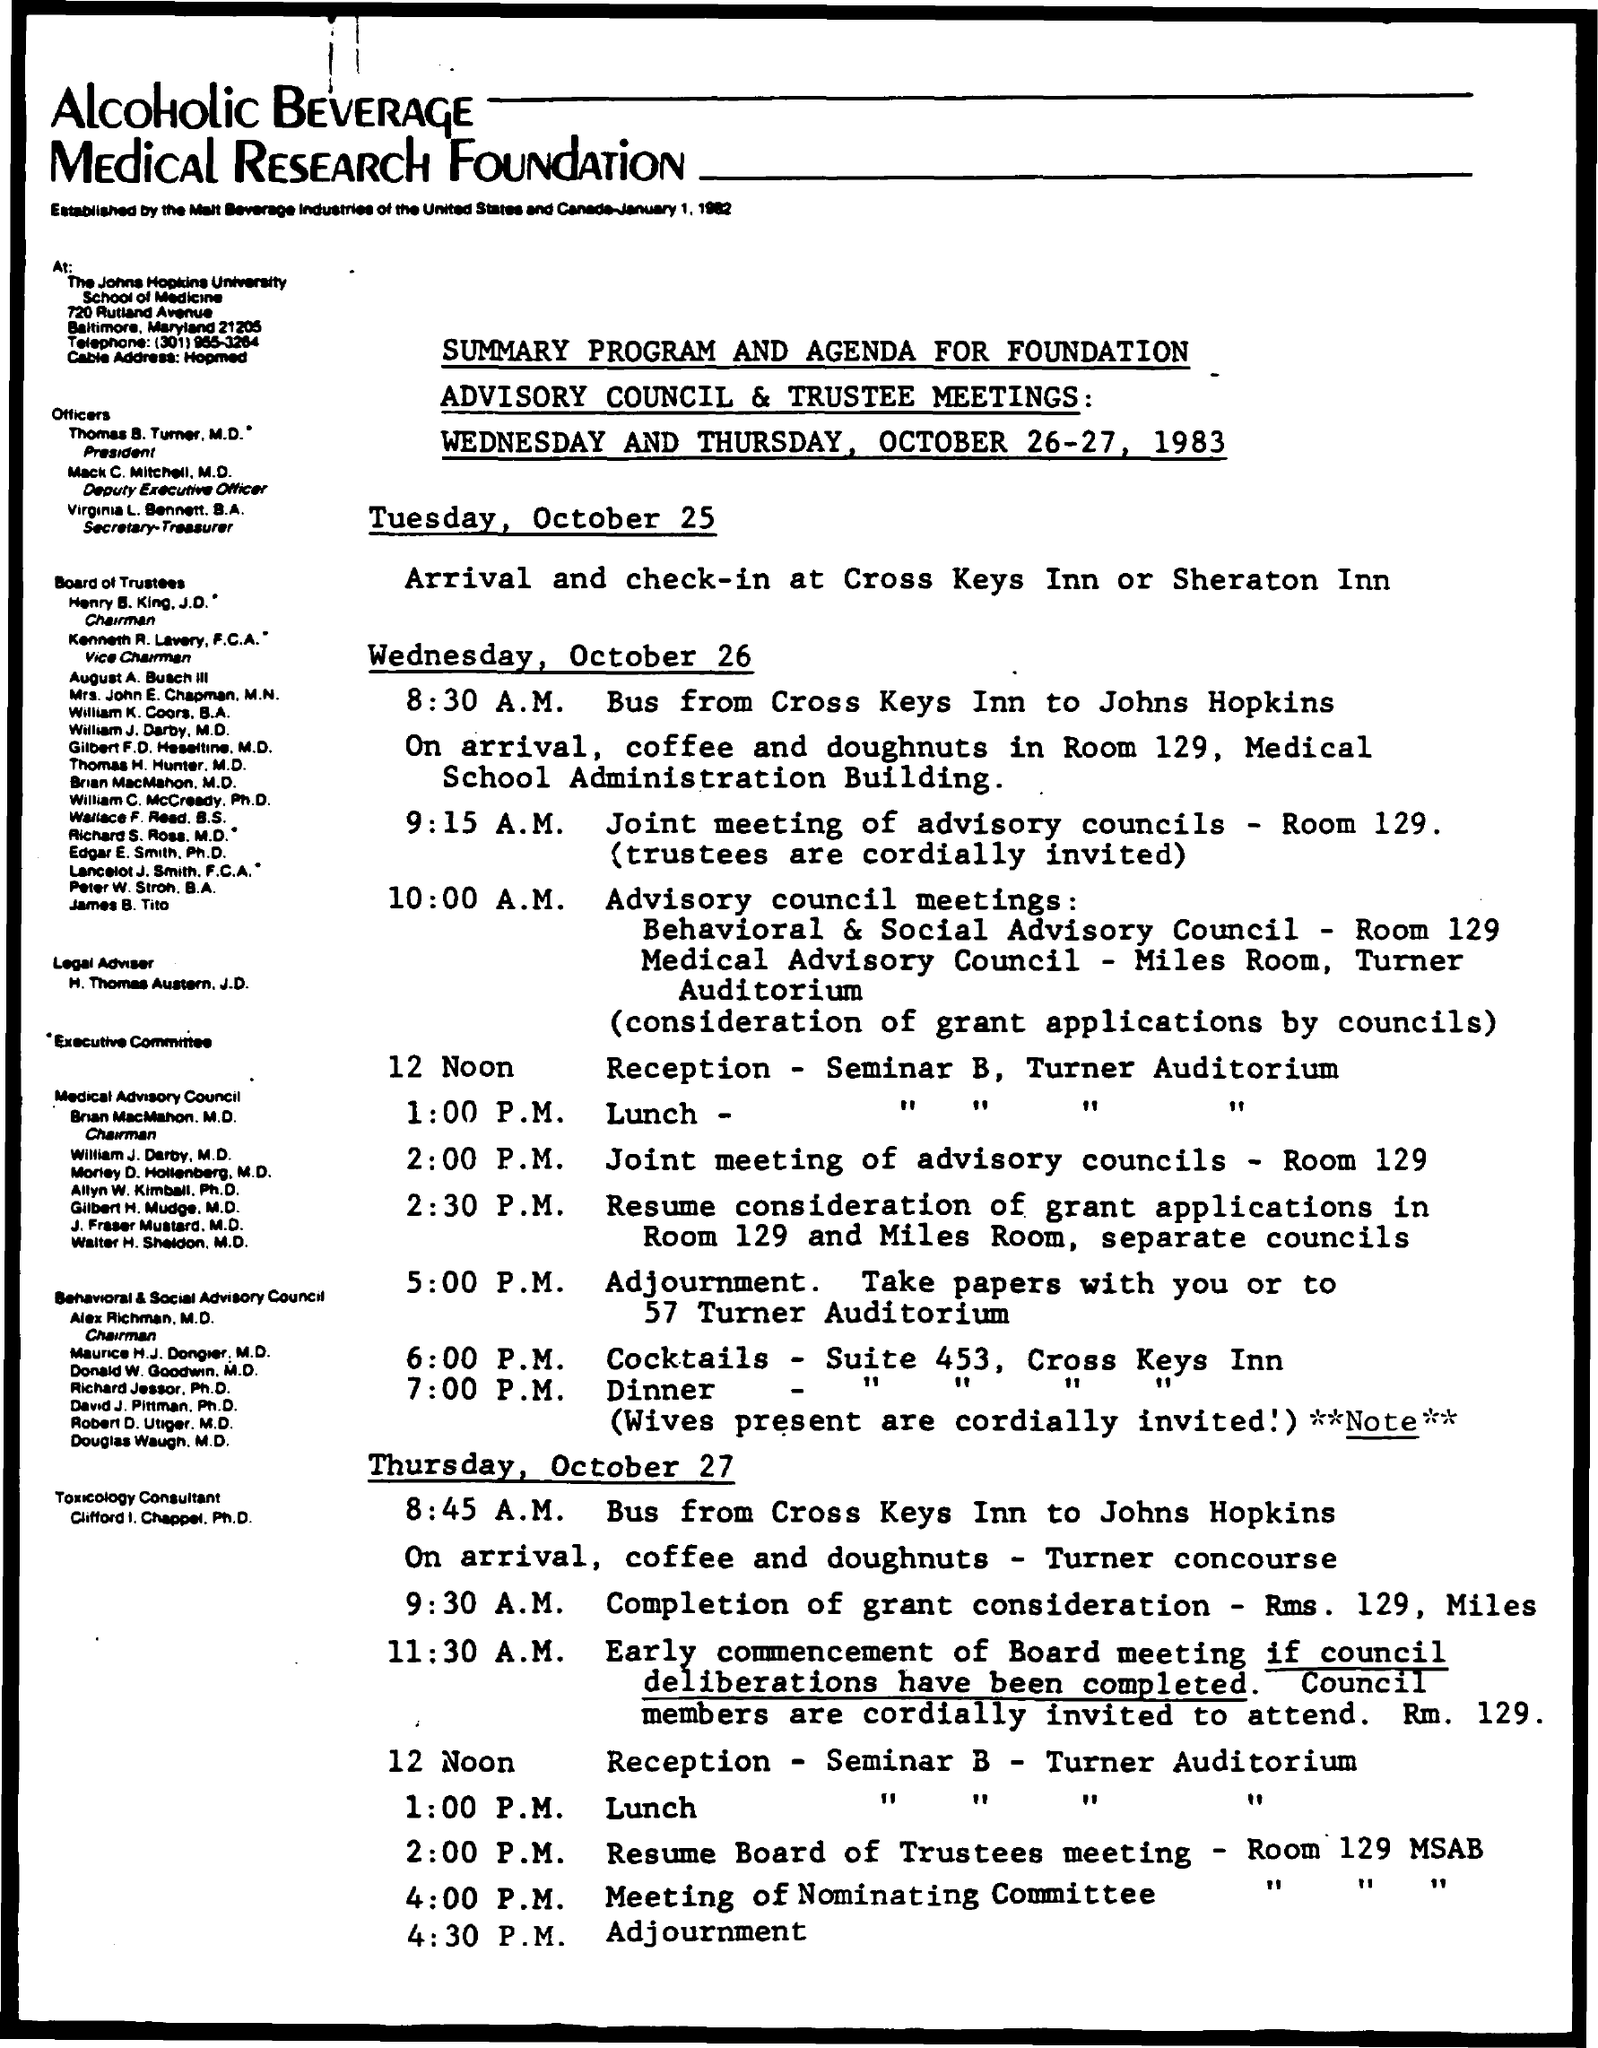What is the lunch time ?
Provide a short and direct response. 1:00 P.M. What is the dinner time ?
Ensure brevity in your answer.  7:00 P.M. What is the time mentioned for cocktails
Give a very brief answer. 6:00 P.M. What is the room no for resume board of trustees meeting ?
Keep it short and to the point. Room 129 MSAB. What is the venue for arrival and check - in ?
Your answer should be very brief. Cross Keys Inn or Sheraton Inn. What is the room no for joint meeting of advisory councils
Offer a terse response. Room 129. 